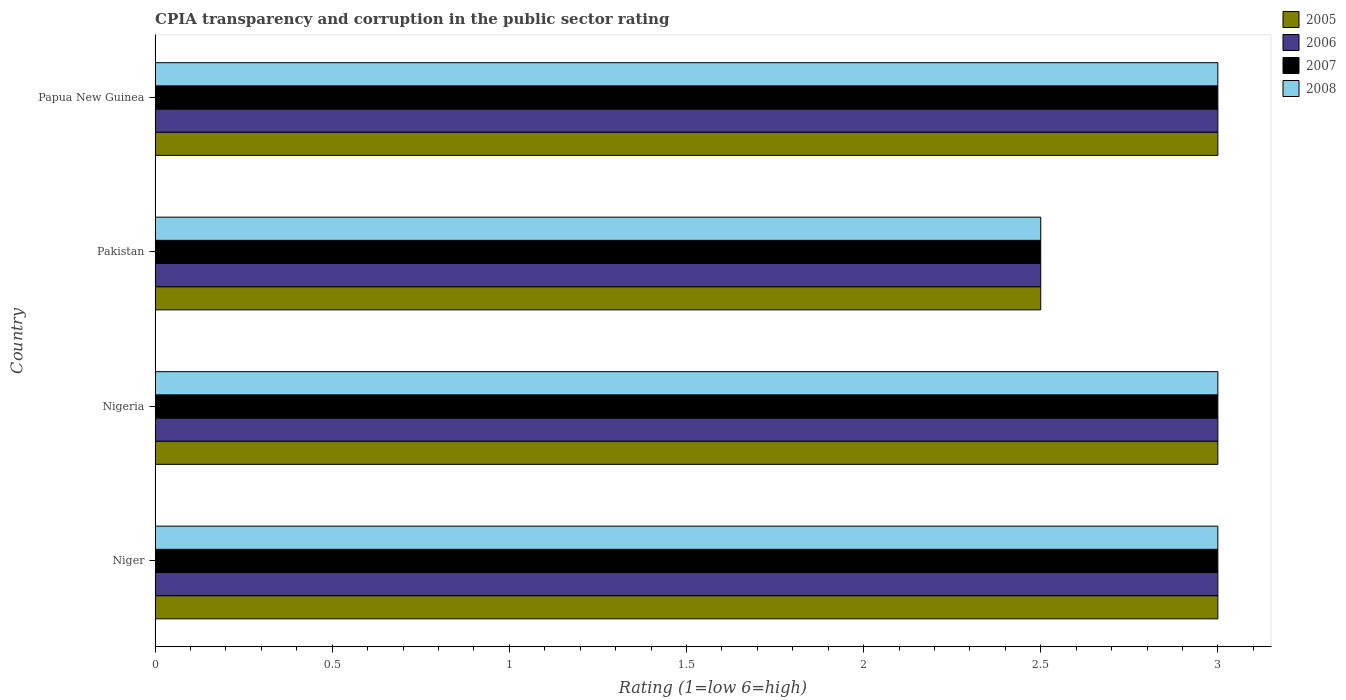How many different coloured bars are there?
Your answer should be very brief. 4. Are the number of bars per tick equal to the number of legend labels?
Ensure brevity in your answer.  Yes. Are the number of bars on each tick of the Y-axis equal?
Provide a succinct answer. Yes. How many bars are there on the 4th tick from the bottom?
Offer a terse response. 4. What is the label of the 1st group of bars from the top?
Offer a very short reply. Papua New Guinea. In how many cases, is the number of bars for a given country not equal to the number of legend labels?
Your answer should be very brief. 0. What is the CPIA rating in 2005 in Pakistan?
Ensure brevity in your answer.  2.5. Across all countries, what is the maximum CPIA rating in 2008?
Your response must be concise. 3. Across all countries, what is the minimum CPIA rating in 2008?
Provide a short and direct response. 2.5. In which country was the CPIA rating in 2006 maximum?
Your answer should be compact. Niger. What is the total CPIA rating in 2007 in the graph?
Your answer should be very brief. 11.5. What is the difference between the CPIA rating in 2008 in Papua New Guinea and the CPIA rating in 2005 in Niger?
Your answer should be compact. 0. What is the average CPIA rating in 2007 per country?
Keep it short and to the point. 2.88. What is the difference between the CPIA rating in 2006 and CPIA rating in 2005 in Nigeria?
Keep it short and to the point. 0. What is the ratio of the CPIA rating in 2007 in Pakistan to that in Papua New Guinea?
Make the answer very short. 0.83. Is the difference between the CPIA rating in 2006 in Niger and Papua New Guinea greater than the difference between the CPIA rating in 2005 in Niger and Papua New Guinea?
Provide a succinct answer. No. What is the difference between the highest and the second highest CPIA rating in 2007?
Make the answer very short. 0. What is the difference between the highest and the lowest CPIA rating in 2005?
Your answer should be very brief. 0.5. In how many countries, is the CPIA rating in 2005 greater than the average CPIA rating in 2005 taken over all countries?
Make the answer very short. 3. What does the 3rd bar from the top in Pakistan represents?
Provide a short and direct response. 2006. How many countries are there in the graph?
Give a very brief answer. 4. Does the graph contain any zero values?
Provide a short and direct response. No. Does the graph contain grids?
Provide a succinct answer. No. Where does the legend appear in the graph?
Provide a succinct answer. Top right. What is the title of the graph?
Make the answer very short. CPIA transparency and corruption in the public sector rating. Does "1992" appear as one of the legend labels in the graph?
Your answer should be very brief. No. What is the Rating (1=low 6=high) of 2005 in Niger?
Keep it short and to the point. 3. What is the Rating (1=low 6=high) of 2006 in Niger?
Provide a short and direct response. 3. What is the Rating (1=low 6=high) in 2006 in Pakistan?
Offer a very short reply. 2.5. What is the Rating (1=low 6=high) in 2007 in Pakistan?
Your response must be concise. 2.5. What is the Rating (1=low 6=high) in 2005 in Papua New Guinea?
Your answer should be compact. 3. What is the Rating (1=low 6=high) of 2006 in Papua New Guinea?
Your response must be concise. 3. What is the Rating (1=low 6=high) of 2008 in Papua New Guinea?
Give a very brief answer. 3. Across all countries, what is the maximum Rating (1=low 6=high) of 2005?
Provide a succinct answer. 3. Across all countries, what is the maximum Rating (1=low 6=high) in 2006?
Ensure brevity in your answer.  3. Across all countries, what is the minimum Rating (1=low 6=high) in 2005?
Your answer should be very brief. 2.5. What is the total Rating (1=low 6=high) of 2005 in the graph?
Make the answer very short. 11.5. What is the total Rating (1=low 6=high) of 2006 in the graph?
Your answer should be very brief. 11.5. What is the total Rating (1=low 6=high) of 2007 in the graph?
Make the answer very short. 11.5. What is the difference between the Rating (1=low 6=high) of 2005 in Niger and that in Nigeria?
Offer a very short reply. 0. What is the difference between the Rating (1=low 6=high) in 2006 in Niger and that in Nigeria?
Your response must be concise. 0. What is the difference between the Rating (1=low 6=high) in 2007 in Niger and that in Nigeria?
Provide a succinct answer. 0. What is the difference between the Rating (1=low 6=high) in 2006 in Niger and that in Pakistan?
Your answer should be very brief. 0.5. What is the difference between the Rating (1=low 6=high) of 2006 in Niger and that in Papua New Guinea?
Keep it short and to the point. 0. What is the difference between the Rating (1=low 6=high) of 2007 in Niger and that in Papua New Guinea?
Ensure brevity in your answer.  0. What is the difference between the Rating (1=low 6=high) in 2008 in Niger and that in Papua New Guinea?
Ensure brevity in your answer.  0. What is the difference between the Rating (1=low 6=high) in 2005 in Nigeria and that in Pakistan?
Give a very brief answer. 0.5. What is the difference between the Rating (1=low 6=high) in 2006 in Nigeria and that in Pakistan?
Ensure brevity in your answer.  0.5. What is the difference between the Rating (1=low 6=high) in 2007 in Nigeria and that in Pakistan?
Offer a very short reply. 0.5. What is the difference between the Rating (1=low 6=high) in 2008 in Nigeria and that in Pakistan?
Make the answer very short. 0.5. What is the difference between the Rating (1=low 6=high) in 2006 in Nigeria and that in Papua New Guinea?
Provide a succinct answer. 0. What is the difference between the Rating (1=low 6=high) of 2008 in Nigeria and that in Papua New Guinea?
Keep it short and to the point. 0. What is the difference between the Rating (1=low 6=high) in 2006 in Pakistan and that in Papua New Guinea?
Provide a succinct answer. -0.5. What is the difference between the Rating (1=low 6=high) in 2007 in Pakistan and that in Papua New Guinea?
Your response must be concise. -0.5. What is the difference between the Rating (1=low 6=high) of 2008 in Pakistan and that in Papua New Guinea?
Ensure brevity in your answer.  -0.5. What is the difference between the Rating (1=low 6=high) in 2005 in Niger and the Rating (1=low 6=high) in 2006 in Nigeria?
Give a very brief answer. 0. What is the difference between the Rating (1=low 6=high) of 2005 in Niger and the Rating (1=low 6=high) of 2007 in Pakistan?
Offer a terse response. 0.5. What is the difference between the Rating (1=low 6=high) of 2005 in Niger and the Rating (1=low 6=high) of 2008 in Pakistan?
Offer a terse response. 0.5. What is the difference between the Rating (1=low 6=high) in 2006 in Niger and the Rating (1=low 6=high) in 2008 in Pakistan?
Provide a succinct answer. 0.5. What is the difference between the Rating (1=low 6=high) of 2007 in Niger and the Rating (1=low 6=high) of 2008 in Pakistan?
Your answer should be compact. 0.5. What is the difference between the Rating (1=low 6=high) in 2006 in Niger and the Rating (1=low 6=high) in 2008 in Papua New Guinea?
Give a very brief answer. 0. What is the difference between the Rating (1=low 6=high) in 2005 in Nigeria and the Rating (1=low 6=high) in 2006 in Pakistan?
Your response must be concise. 0.5. What is the difference between the Rating (1=low 6=high) of 2006 in Nigeria and the Rating (1=low 6=high) of 2008 in Pakistan?
Provide a succinct answer. 0.5. What is the difference between the Rating (1=low 6=high) of 2007 in Nigeria and the Rating (1=low 6=high) of 2008 in Pakistan?
Ensure brevity in your answer.  0.5. What is the difference between the Rating (1=low 6=high) in 2005 in Nigeria and the Rating (1=low 6=high) in 2006 in Papua New Guinea?
Your answer should be very brief. 0. What is the difference between the Rating (1=low 6=high) of 2005 in Nigeria and the Rating (1=low 6=high) of 2008 in Papua New Guinea?
Make the answer very short. 0. What is the difference between the Rating (1=low 6=high) of 2006 in Nigeria and the Rating (1=low 6=high) of 2007 in Papua New Guinea?
Your answer should be very brief. 0. What is the difference between the Rating (1=low 6=high) in 2005 in Pakistan and the Rating (1=low 6=high) in 2006 in Papua New Guinea?
Your response must be concise. -0.5. What is the difference between the Rating (1=low 6=high) in 2005 in Pakistan and the Rating (1=low 6=high) in 2008 in Papua New Guinea?
Your answer should be very brief. -0.5. What is the difference between the Rating (1=low 6=high) of 2006 in Pakistan and the Rating (1=low 6=high) of 2007 in Papua New Guinea?
Your answer should be compact. -0.5. What is the average Rating (1=low 6=high) of 2005 per country?
Your response must be concise. 2.88. What is the average Rating (1=low 6=high) of 2006 per country?
Your answer should be compact. 2.88. What is the average Rating (1=low 6=high) of 2007 per country?
Your answer should be compact. 2.88. What is the average Rating (1=low 6=high) in 2008 per country?
Your answer should be very brief. 2.88. What is the difference between the Rating (1=low 6=high) of 2005 and Rating (1=low 6=high) of 2006 in Niger?
Provide a succinct answer. 0. What is the difference between the Rating (1=low 6=high) in 2005 and Rating (1=low 6=high) in 2007 in Niger?
Make the answer very short. 0. What is the difference between the Rating (1=low 6=high) of 2007 and Rating (1=low 6=high) of 2008 in Niger?
Offer a terse response. 0. What is the difference between the Rating (1=low 6=high) of 2005 and Rating (1=low 6=high) of 2006 in Nigeria?
Your answer should be very brief. 0. What is the difference between the Rating (1=low 6=high) in 2005 and Rating (1=low 6=high) in 2007 in Nigeria?
Provide a short and direct response. 0. What is the difference between the Rating (1=low 6=high) of 2006 and Rating (1=low 6=high) of 2008 in Nigeria?
Make the answer very short. 0. What is the difference between the Rating (1=low 6=high) of 2005 and Rating (1=low 6=high) of 2007 in Pakistan?
Keep it short and to the point. 0. What is the difference between the Rating (1=low 6=high) of 2006 and Rating (1=low 6=high) of 2007 in Pakistan?
Ensure brevity in your answer.  0. What is the difference between the Rating (1=low 6=high) of 2007 and Rating (1=low 6=high) of 2008 in Pakistan?
Your answer should be compact. 0. What is the difference between the Rating (1=low 6=high) of 2005 and Rating (1=low 6=high) of 2007 in Papua New Guinea?
Provide a short and direct response. 0. What is the difference between the Rating (1=low 6=high) in 2005 and Rating (1=low 6=high) in 2008 in Papua New Guinea?
Provide a succinct answer. 0. What is the difference between the Rating (1=low 6=high) of 2006 and Rating (1=low 6=high) of 2008 in Papua New Guinea?
Offer a terse response. 0. What is the ratio of the Rating (1=low 6=high) in 2006 in Niger to that in Nigeria?
Your answer should be very brief. 1. What is the ratio of the Rating (1=low 6=high) in 2007 in Niger to that in Nigeria?
Your response must be concise. 1. What is the ratio of the Rating (1=low 6=high) in 2008 in Niger to that in Papua New Guinea?
Provide a succinct answer. 1. What is the ratio of the Rating (1=low 6=high) of 2006 in Nigeria to that in Pakistan?
Keep it short and to the point. 1.2. What is the ratio of the Rating (1=low 6=high) in 2007 in Nigeria to that in Pakistan?
Offer a terse response. 1.2. What is the ratio of the Rating (1=low 6=high) of 2008 in Nigeria to that in Pakistan?
Provide a short and direct response. 1.2. What is the ratio of the Rating (1=low 6=high) in 2006 in Nigeria to that in Papua New Guinea?
Give a very brief answer. 1. What is the ratio of the Rating (1=low 6=high) of 2008 in Nigeria to that in Papua New Guinea?
Offer a very short reply. 1. What is the ratio of the Rating (1=low 6=high) in 2005 in Pakistan to that in Papua New Guinea?
Keep it short and to the point. 0.83. What is the ratio of the Rating (1=low 6=high) of 2007 in Pakistan to that in Papua New Guinea?
Your response must be concise. 0.83. What is the difference between the highest and the lowest Rating (1=low 6=high) of 2006?
Give a very brief answer. 0.5. What is the difference between the highest and the lowest Rating (1=low 6=high) in 2007?
Offer a very short reply. 0.5. 